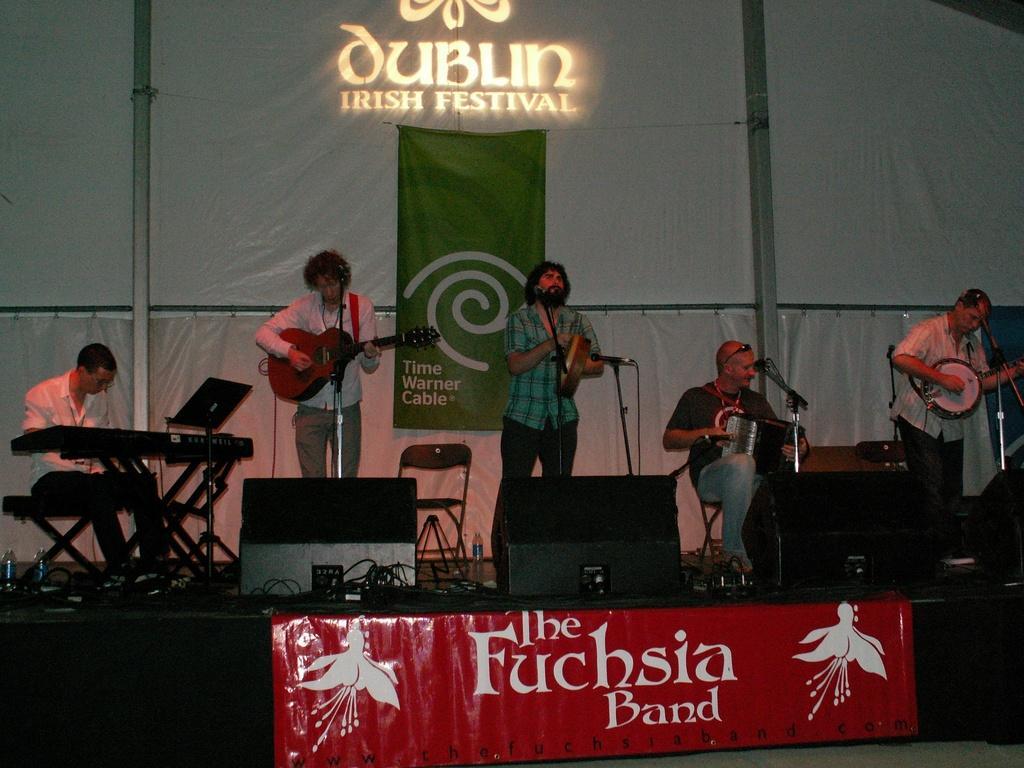Can you describe this image briefly? In the image we can see there are people who are holding guitar and other musical instruments in their hand. Other people are sitting and playing music on the stage there are speakers and at the back there is banner. 